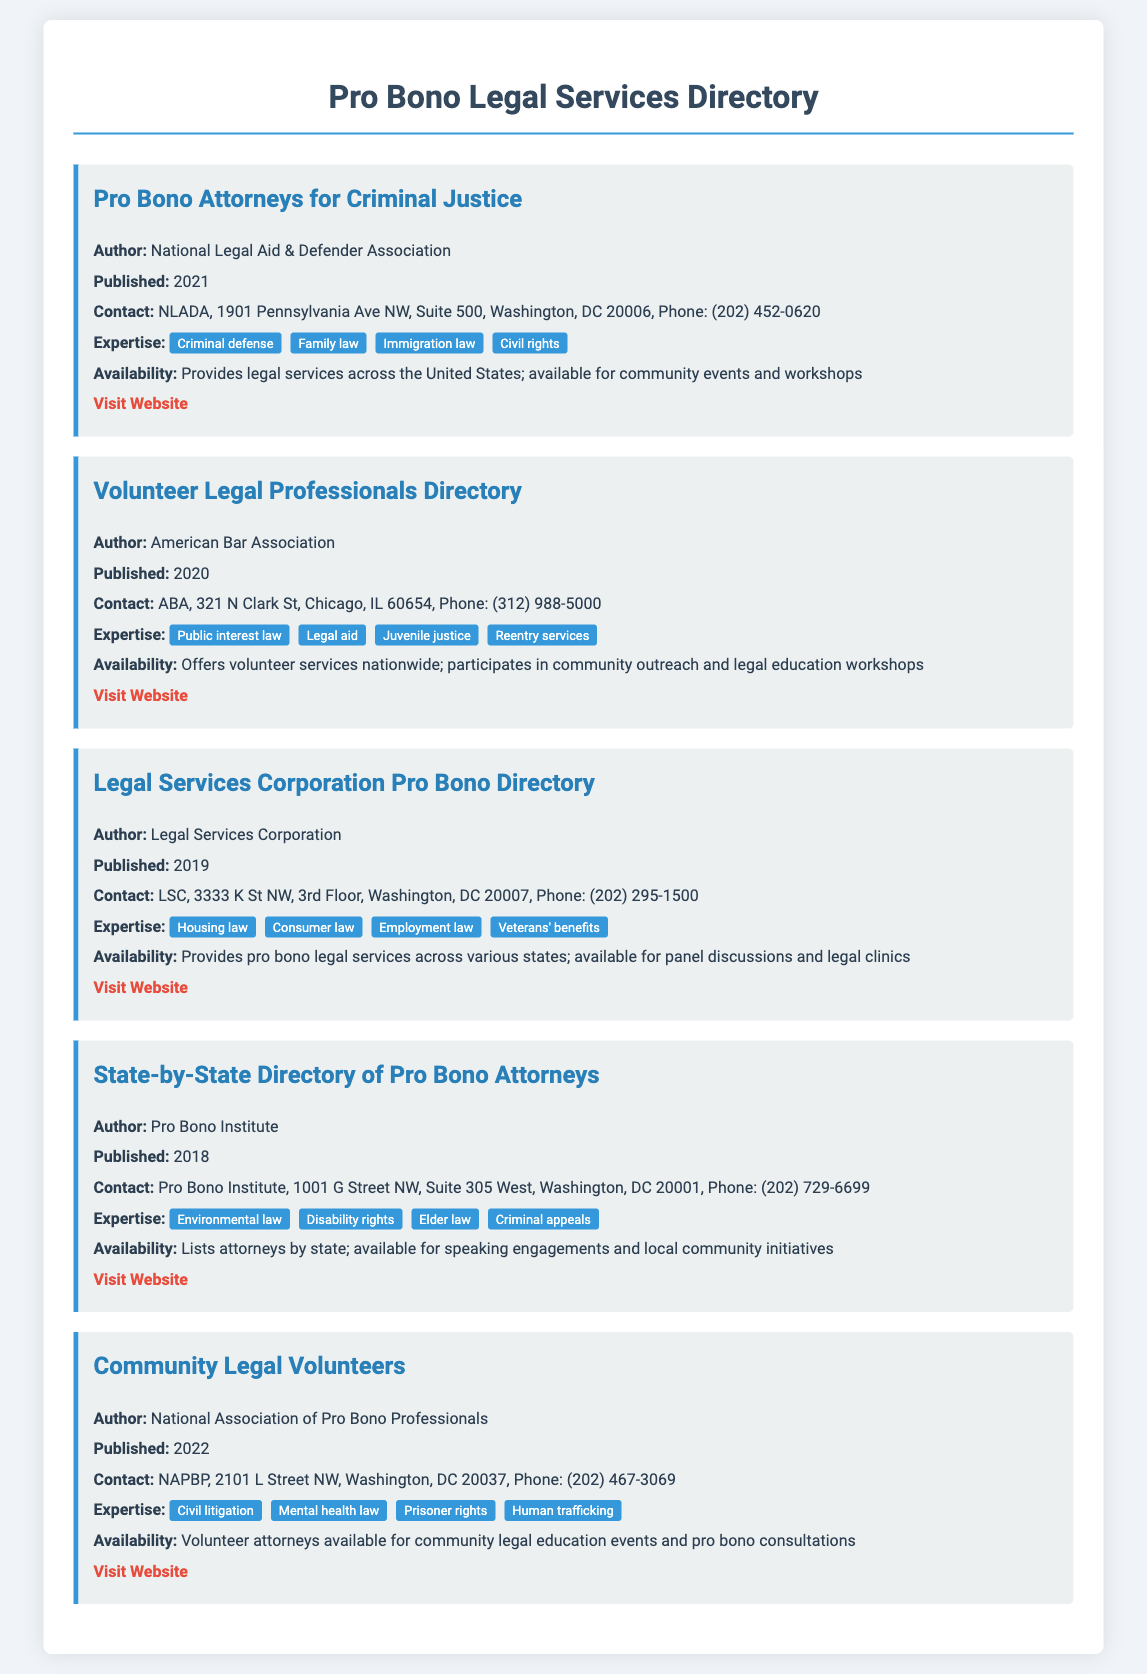what is the title of the first entry? The title of the first entry is found in the heading section of the entry, which is "Pro Bono Attorneys for Criminal Justice."
Answer: Pro Bono Attorneys for Criminal Justice who is the author of the "Volunteer Legal Professionals Directory"? The author is specified in the entry as "American Bar Association."
Answer: American Bar Association what is the contact number for the Legal Services Corporation? The contact number is mentioned in the entry as "(202) 295-1500."
Answer: (202) 295-1500 which area of expertise is listed under the "Community Legal Volunteers"? The areas of expertise are listed in the entry, one of which is "Civil litigation."
Answer: Civil litigation how many entries are focused on criminal justice? The document contains two entries that focus on criminal justice: "Pro Bono Attorneys for Criminal Justice" and "State-by-State Directory of Pro Bono Attorneys."
Answer: 2 what is the publication year of the "Legal Services Corporation Pro Bono Directory"? The publication year is provided in the document and is "2019."
Answer: 2019 which organization provides services across the United States? This detail is provided for multiple organizations in the document; one such organization is the "National Legal Aid & Defender Association."
Answer: National Legal Aid & Defender Association how many areas of expertise are listed for the entry titled "Volunteer Legal Professionals Directory"? The entry lists four specific areas of expertise under this title.
Answer: 4 